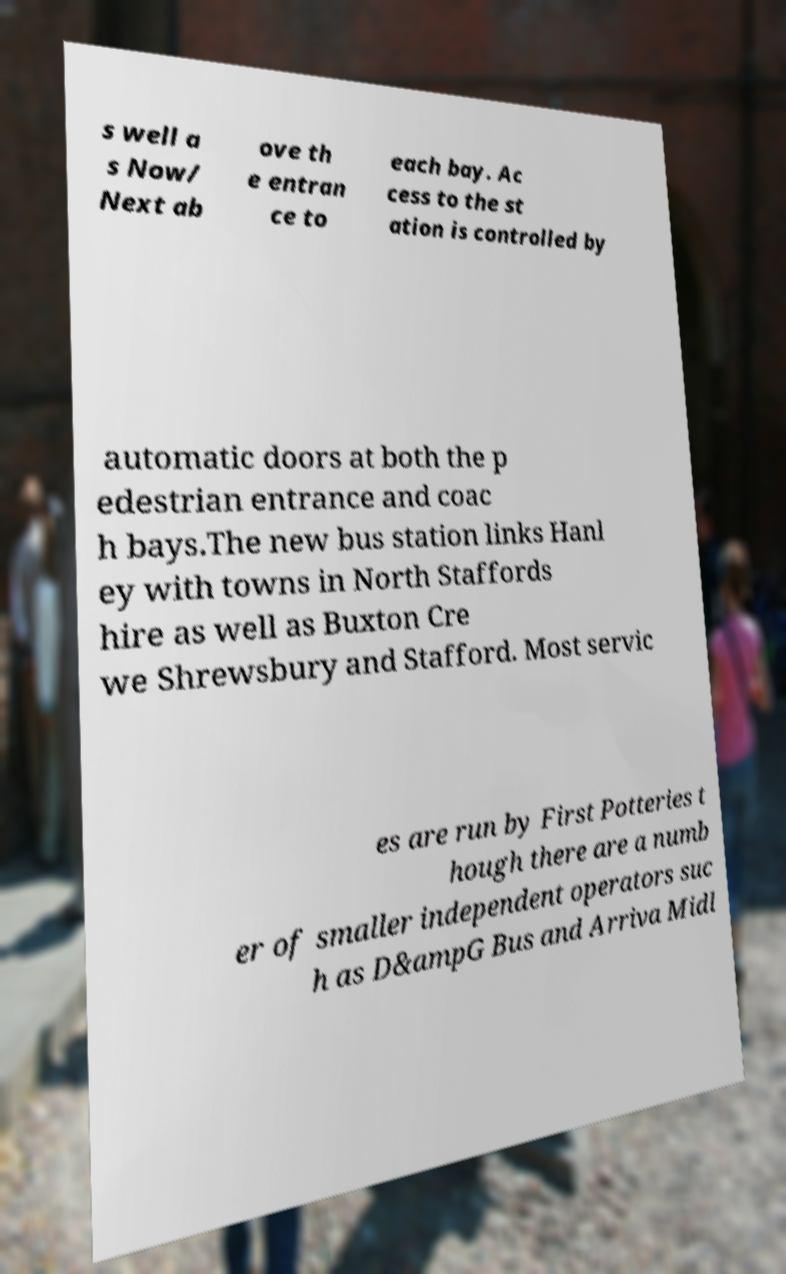Please read and relay the text visible in this image. What does it say? s well a s Now/ Next ab ove th e entran ce to each bay. Ac cess to the st ation is controlled by automatic doors at both the p edestrian entrance and coac h bays.The new bus station links Hanl ey with towns in North Staffords hire as well as Buxton Cre we Shrewsbury and Stafford. Most servic es are run by First Potteries t hough there are a numb er of smaller independent operators suc h as D&ampG Bus and Arriva Midl 